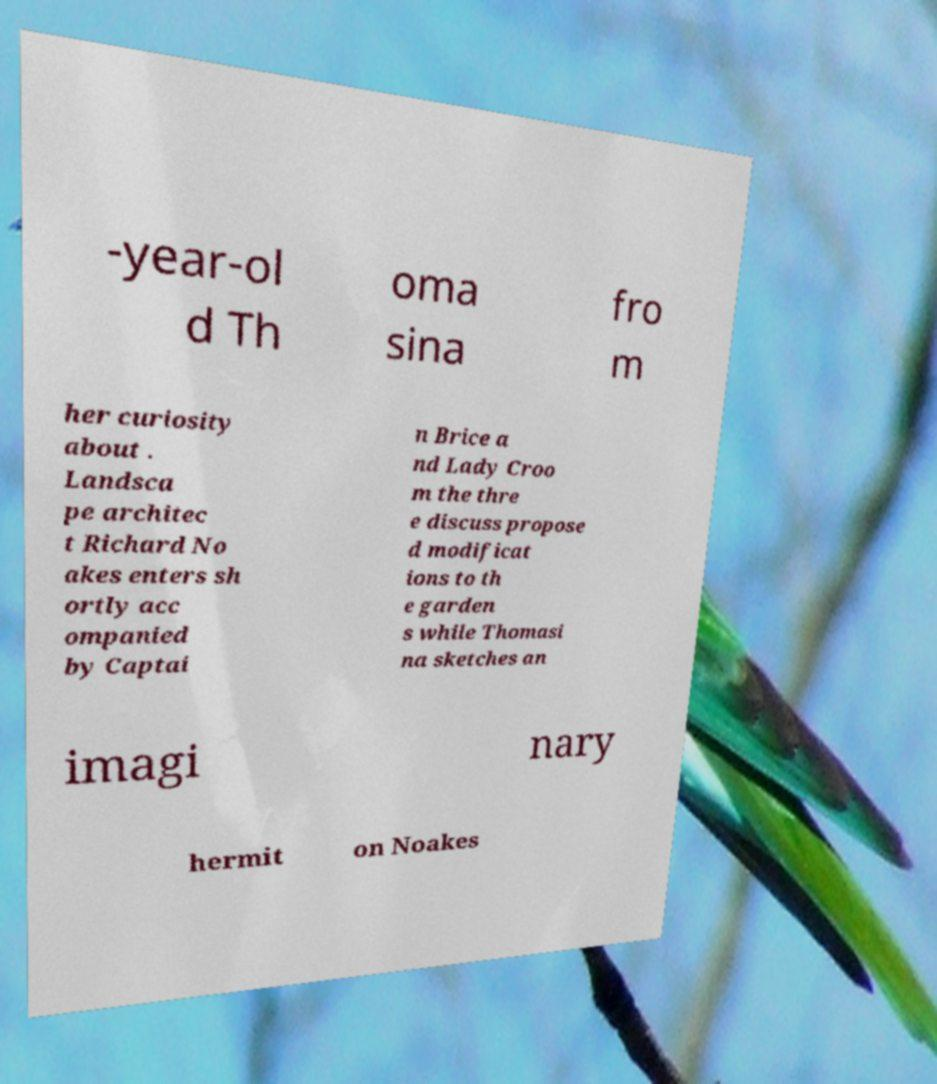Could you extract and type out the text from this image? -year-ol d Th oma sina fro m her curiosity about . Landsca pe architec t Richard No akes enters sh ortly acc ompanied by Captai n Brice a nd Lady Croo m the thre e discuss propose d modificat ions to th e garden s while Thomasi na sketches an imagi nary hermit on Noakes 